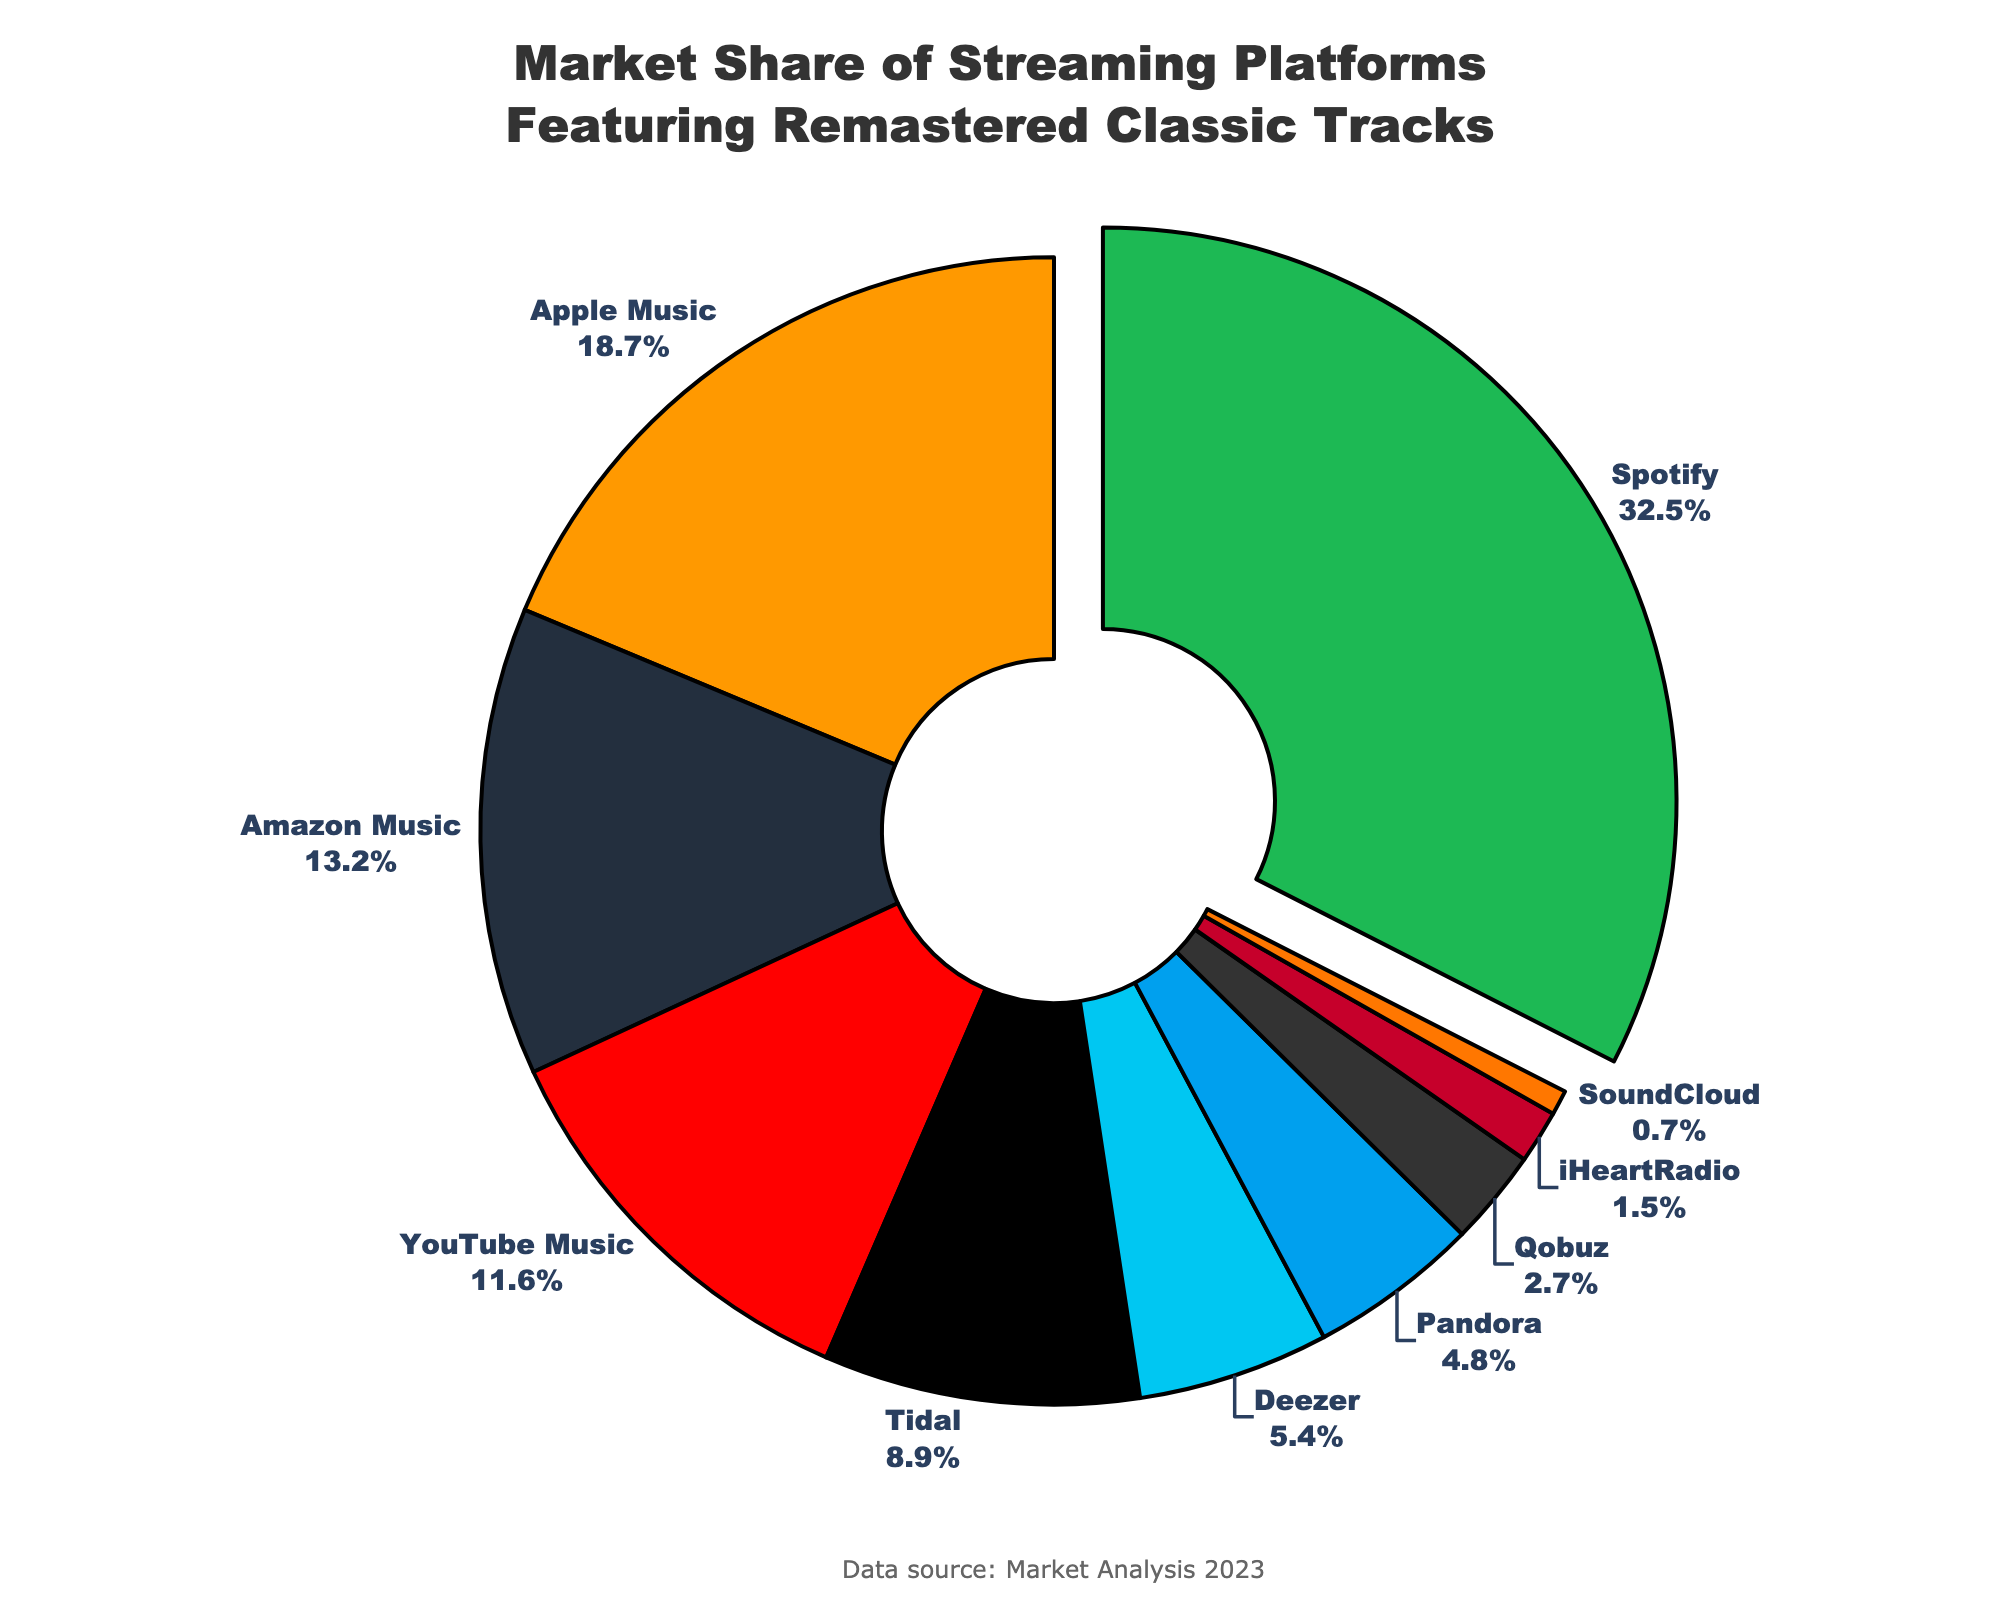Which streaming platform has the highest market share? Look at the pie chart, the segment that is pulled out represents the platform with the highest market share. This segment is labeled Spotify.
Answer: Spotify What is the total market share of Amazon Music and YouTube Music combined? Observe the market shares for Amazon Music (13.2%) and YouTube Music (11.6%). Add these values: 13.2 + 11.6 = 24.8%.
Answer: 24.8% Which platform has a slightly higher market share, Tidal or Deezer? Tidal has a market share of 8.9%, while Deezer has 5.4%. Compare these values to see Tidal has the higher market share.
Answer: Tidal How much larger is Spotify's market share compared to Qobuz? Spotify's market share is 32.5% and Qobuz's is 2.7%. Subtract Qobuz's share from Spotify's share: 32.5 - 2.7 = 29.8%.
Answer: 29.8% Which streaming platforms have a market share smaller than 5%? Look at the segments labeled with market shares. Identify those less than 5%: Pandora (4.8%), Qobuz (2.7%), iHeartRadio (1.5%), and SoundCloud (0.7%).
Answer: Pandora, Qobuz, iHeartRadio, SoundCloud What percentage of the market share do platforms other than Spotify hold? Calculate the total market share of all platforms (100%) and subtract the market share of Spotify (32.5%). This results in 100 - 32.5 = 67.5%.
Answer: 67.5% Which platforms have market shares that are close to the average market share value? First, find the average market share by summing all shares and dividing by the number of platforms: (32.5 + 18.7 + 13.2 + 11.6 + 8.9 + 5.4 + 4.8 + 2.7 + 1.5 + 0.7) / 10 = 10%. The shares closest to 10% are YouTube Music (11.6%) and Tidal (8.9%).
Answer: YouTube Music, Tidal Are there more platforms with market shares above 10% or below 5%? Count the numbers of platforms in each category. Above 10%: Spotify (1), Apple Music (1), Amazon Music (1), YouTube Music (1). Below 5%: Pandora (1), Qobuz (1), iHeartRadio (1), SoundCloud (1). Both have 4 platforms each.
Answer: Equal How do the market shares of Apple Music and Amazon Music compare visually on the chart? Observe the pie chart segments for Apple Music (18.7%) and Amazon Music (13.2%). Apple Music's segment is larger and positioned next to Spotify's, while Amazon Music's is slightly smaller.
Answer: Apple Music has a larger share What is the total market share of platforms other than Spotify, Apple Music, and Amazon Music? Sum the market shares of all platforms except these three: (11.6 + 8.9 + 5.4 + 4.8 + 2.7 + 1.5 + 0.7) = 35.6%.
Answer: 35.6% 